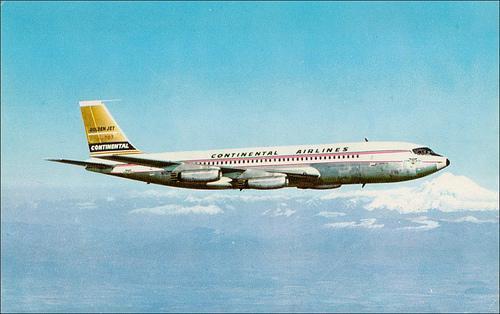How many planes are in the picture?
Give a very brief answer. 1. 